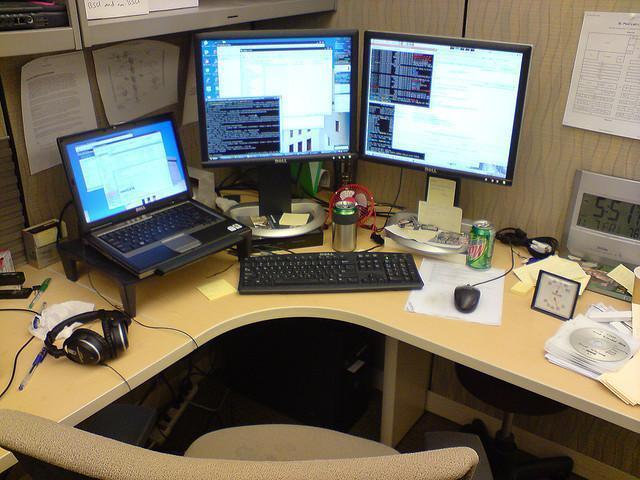How many keyboards are visible?
Give a very brief answer. 2. How many chairs are visible?
Give a very brief answer. 2. How many people are in front of the buses?
Give a very brief answer. 0. 